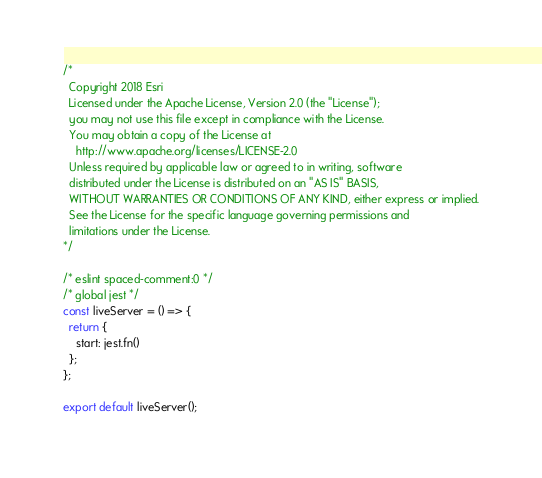Convert code to text. <code><loc_0><loc_0><loc_500><loc_500><_JavaScript_>/*
  Copyright 2018 Esri
  Licensed under the Apache License, Version 2.0 (the "License");
  you may not use this file except in compliance with the License.
  You may obtain a copy of the License at
    http://www.apache.org/licenses/LICENSE-2.0
  Unless required by applicable law or agreed to in writing, software
  distributed under the License is distributed on an "AS IS" BASIS,
  WITHOUT WARRANTIES OR CONDITIONS OF ANY KIND, either express or implied.
  See the License for the specific language governing permissions and
  limitations under the License.
*/

/* eslint spaced-comment:0 */
/* global jest */
const liveServer = () => {
  return {
    start: jest.fn()
  };
};

export default liveServer();
</code> 